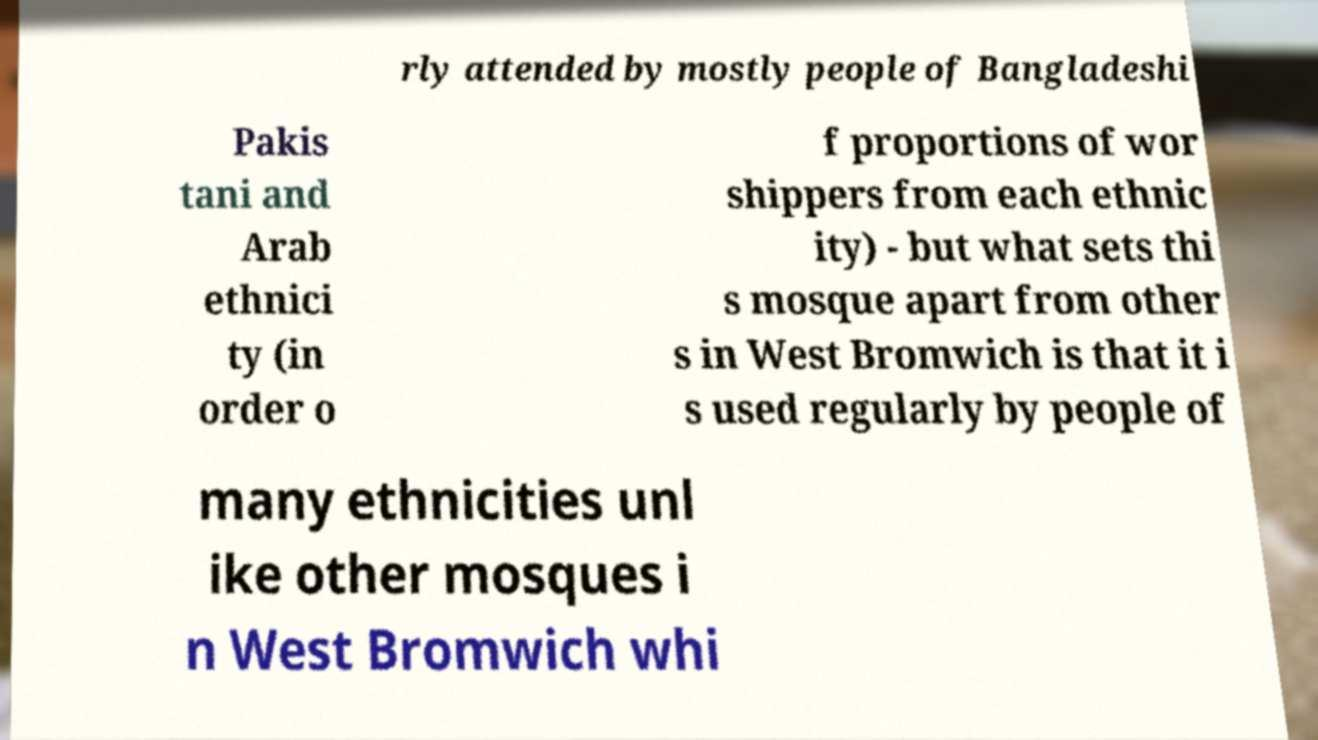Can you accurately transcribe the text from the provided image for me? rly attended by mostly people of Bangladeshi Pakis tani and Arab ethnici ty (in order o f proportions of wor shippers from each ethnic ity) - but what sets thi s mosque apart from other s in West Bromwich is that it i s used regularly by people of many ethnicities unl ike other mosques i n West Bromwich whi 